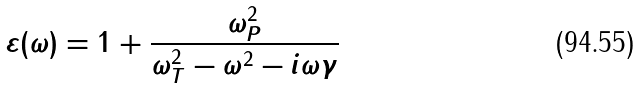<formula> <loc_0><loc_0><loc_500><loc_500>\varepsilon ( \omega ) = 1 + \frac { \omega _ { P } ^ { 2 } } { \omega _ { T } ^ { 2 } - \omega ^ { 2 } - i \omega \gamma }</formula> 